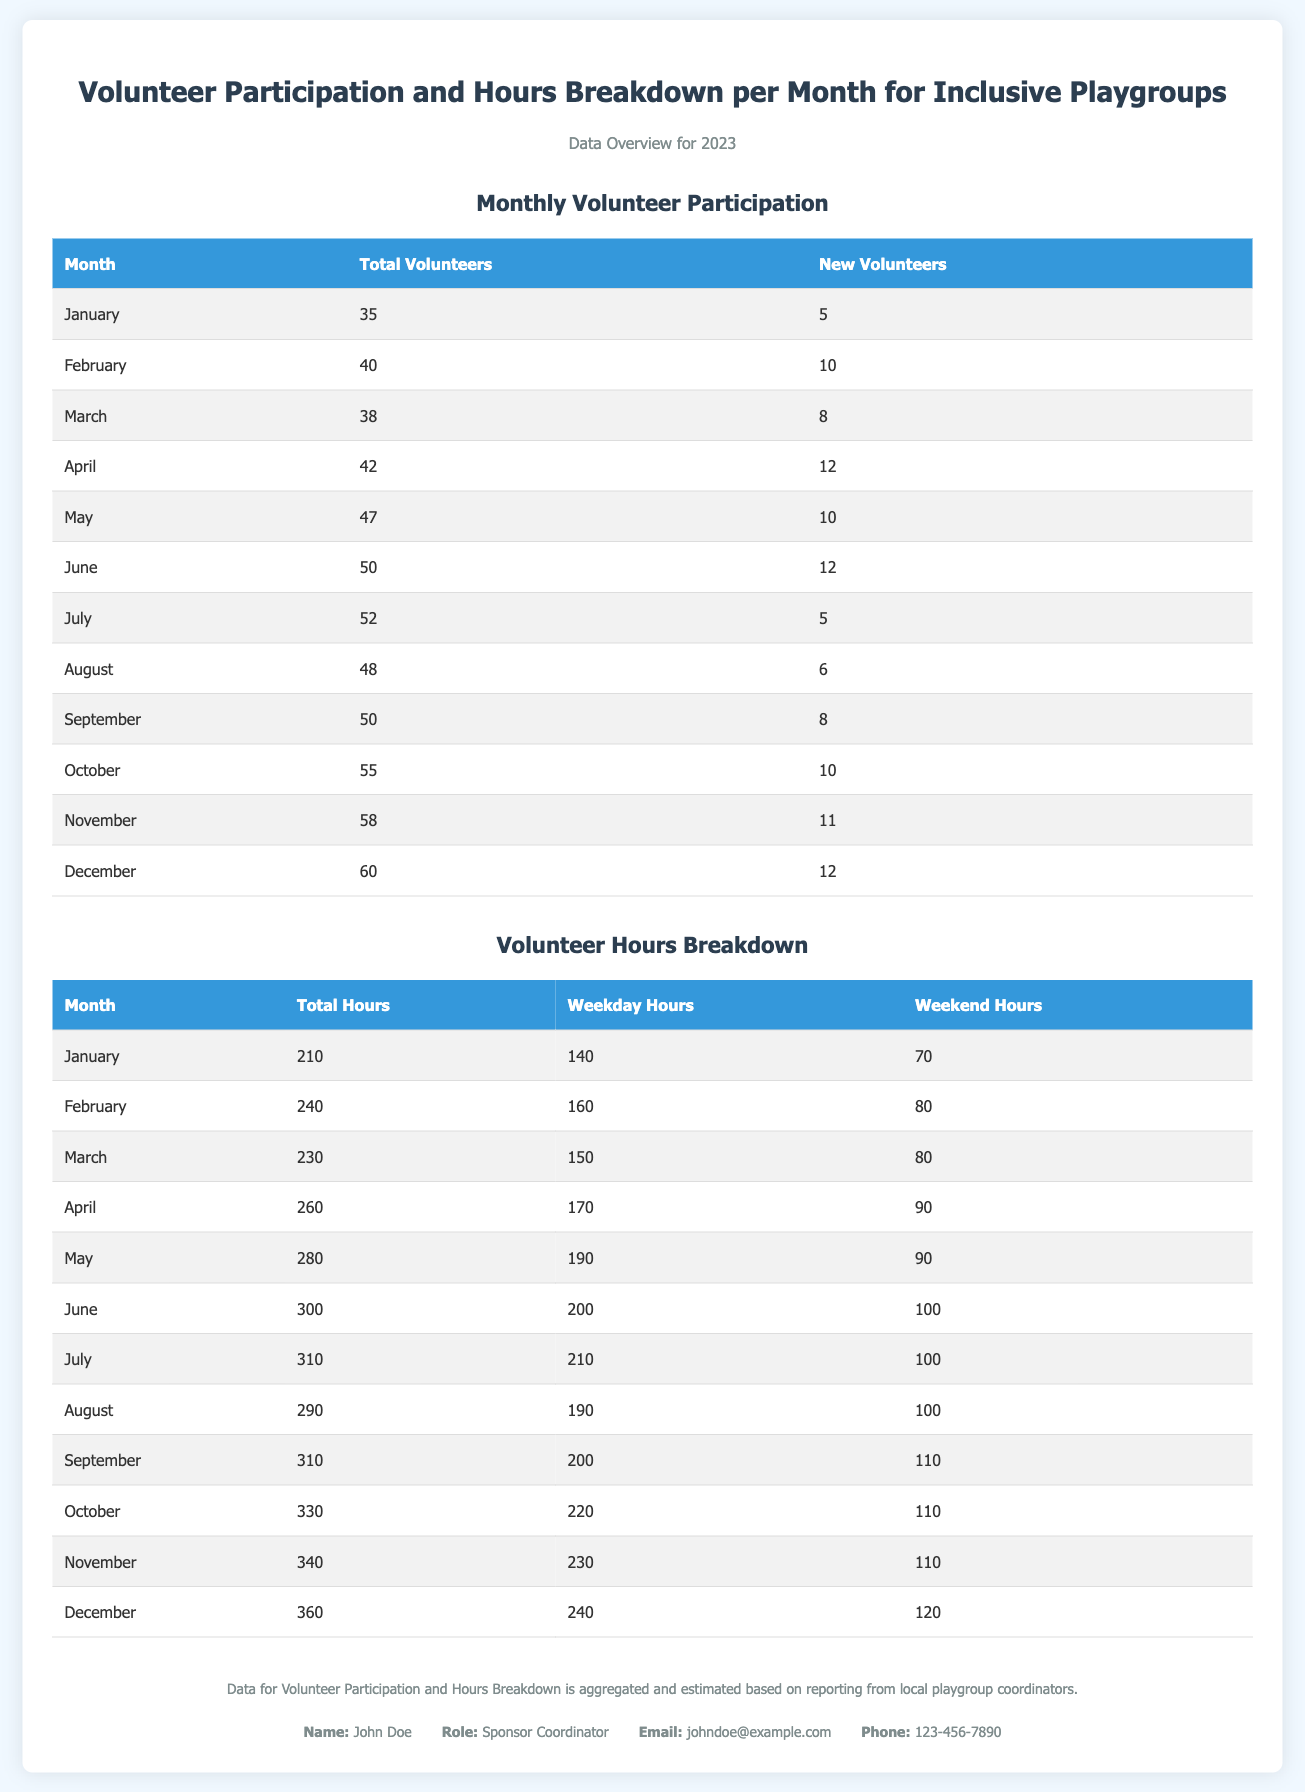what is the total number of volunteers in December? The total number of volunteers in December is listed in the table under Monthly Volunteer Participation.
Answer: 60 how many new volunteers were there in April? The number of new volunteers for April is shown in the Monthly Volunteer Participation table.
Answer: 12 what was the total volunteer hours in June? The total volunteer hours for June are listed in the Volunteer Hours Breakdown table.
Answer: 300 which month had the highest total hours? The highest total hours can be determined by comparing the total hours across all months in the Volunteer Hours Breakdown table.
Answer: December how many weekday hours were recorded in October? The number of weekday hours in October is found in the Volunteer Hours Breakdown table.
Answer: 220 which month had the lowest new volunteers? To find this, compare the new volunteer numbers from each month in the Monthly Volunteer Participation table.
Answer: January what was the total volunteer hours for January? The total volunteer hours for January are mentioned in the Volunteer Hours Breakdown table.
Answer: 210 in which month did the number of total volunteers exceed 50? This can be found by reviewing the Monthly Volunteer Participation table and identifying months with total volunteers over 50.
Answer: July how many total hours were worked on weekends in August? The total weekend hours for August are indicated in the Volunteer Hours Breakdown table.
Answer: 100 